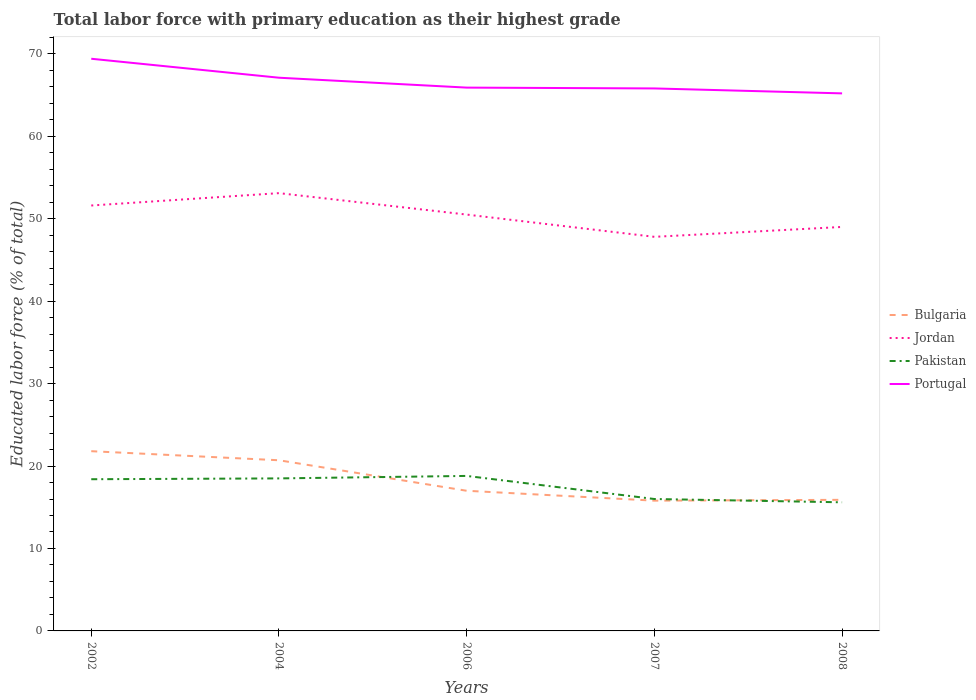Is the number of lines equal to the number of legend labels?
Your response must be concise. Yes. Across all years, what is the maximum percentage of total labor force with primary education in Portugal?
Your answer should be very brief. 65.2. In which year was the percentage of total labor force with primary education in Pakistan maximum?
Make the answer very short. 2008. What is the total percentage of total labor force with primary education in Portugal in the graph?
Offer a very short reply. 4.2. What is the difference between the highest and the second highest percentage of total labor force with primary education in Portugal?
Offer a terse response. 4.2. How many lines are there?
Offer a very short reply. 4. What is the difference between two consecutive major ticks on the Y-axis?
Ensure brevity in your answer.  10. Does the graph contain any zero values?
Provide a short and direct response. No. Where does the legend appear in the graph?
Provide a short and direct response. Center right. How are the legend labels stacked?
Your response must be concise. Vertical. What is the title of the graph?
Offer a terse response. Total labor force with primary education as their highest grade. What is the label or title of the Y-axis?
Ensure brevity in your answer.  Educated labor force (% of total). What is the Educated labor force (% of total) of Bulgaria in 2002?
Keep it short and to the point. 21.8. What is the Educated labor force (% of total) in Jordan in 2002?
Make the answer very short. 51.6. What is the Educated labor force (% of total) of Pakistan in 2002?
Your response must be concise. 18.4. What is the Educated labor force (% of total) of Portugal in 2002?
Offer a terse response. 69.4. What is the Educated labor force (% of total) in Bulgaria in 2004?
Offer a terse response. 20.7. What is the Educated labor force (% of total) in Jordan in 2004?
Make the answer very short. 53.1. What is the Educated labor force (% of total) of Pakistan in 2004?
Ensure brevity in your answer.  18.5. What is the Educated labor force (% of total) of Portugal in 2004?
Provide a short and direct response. 67.1. What is the Educated labor force (% of total) in Bulgaria in 2006?
Make the answer very short. 17. What is the Educated labor force (% of total) of Jordan in 2006?
Ensure brevity in your answer.  50.5. What is the Educated labor force (% of total) of Pakistan in 2006?
Keep it short and to the point. 18.8. What is the Educated labor force (% of total) in Portugal in 2006?
Give a very brief answer. 65.9. What is the Educated labor force (% of total) in Bulgaria in 2007?
Give a very brief answer. 15.8. What is the Educated labor force (% of total) in Jordan in 2007?
Keep it short and to the point. 47.8. What is the Educated labor force (% of total) of Portugal in 2007?
Your answer should be very brief. 65.8. What is the Educated labor force (% of total) of Bulgaria in 2008?
Your response must be concise. 15.9. What is the Educated labor force (% of total) of Jordan in 2008?
Make the answer very short. 49. What is the Educated labor force (% of total) in Pakistan in 2008?
Offer a terse response. 15.6. What is the Educated labor force (% of total) in Portugal in 2008?
Provide a short and direct response. 65.2. Across all years, what is the maximum Educated labor force (% of total) in Bulgaria?
Ensure brevity in your answer.  21.8. Across all years, what is the maximum Educated labor force (% of total) in Jordan?
Your response must be concise. 53.1. Across all years, what is the maximum Educated labor force (% of total) of Pakistan?
Provide a short and direct response. 18.8. Across all years, what is the maximum Educated labor force (% of total) in Portugal?
Your answer should be compact. 69.4. Across all years, what is the minimum Educated labor force (% of total) of Bulgaria?
Provide a succinct answer. 15.8. Across all years, what is the minimum Educated labor force (% of total) of Jordan?
Your answer should be very brief. 47.8. Across all years, what is the minimum Educated labor force (% of total) in Pakistan?
Offer a very short reply. 15.6. Across all years, what is the minimum Educated labor force (% of total) of Portugal?
Your answer should be compact. 65.2. What is the total Educated labor force (% of total) in Bulgaria in the graph?
Your answer should be very brief. 91.2. What is the total Educated labor force (% of total) in Jordan in the graph?
Your response must be concise. 252. What is the total Educated labor force (% of total) of Pakistan in the graph?
Ensure brevity in your answer.  87.3. What is the total Educated labor force (% of total) of Portugal in the graph?
Give a very brief answer. 333.4. What is the difference between the Educated labor force (% of total) of Bulgaria in 2002 and that in 2004?
Provide a short and direct response. 1.1. What is the difference between the Educated labor force (% of total) of Jordan in 2002 and that in 2004?
Your response must be concise. -1.5. What is the difference between the Educated labor force (% of total) in Bulgaria in 2002 and that in 2006?
Keep it short and to the point. 4.8. What is the difference between the Educated labor force (% of total) of Portugal in 2002 and that in 2006?
Keep it short and to the point. 3.5. What is the difference between the Educated labor force (% of total) of Jordan in 2002 and that in 2007?
Your answer should be compact. 3.8. What is the difference between the Educated labor force (% of total) in Pakistan in 2002 and that in 2007?
Offer a very short reply. 2.4. What is the difference between the Educated labor force (% of total) of Portugal in 2002 and that in 2007?
Ensure brevity in your answer.  3.6. What is the difference between the Educated labor force (% of total) in Bulgaria in 2002 and that in 2008?
Offer a terse response. 5.9. What is the difference between the Educated labor force (% of total) in Jordan in 2002 and that in 2008?
Your answer should be very brief. 2.6. What is the difference between the Educated labor force (% of total) in Portugal in 2002 and that in 2008?
Ensure brevity in your answer.  4.2. What is the difference between the Educated labor force (% of total) in Bulgaria in 2004 and that in 2007?
Give a very brief answer. 4.9. What is the difference between the Educated labor force (% of total) of Pakistan in 2004 and that in 2007?
Your answer should be very brief. 2.5. What is the difference between the Educated labor force (% of total) in Jordan in 2004 and that in 2008?
Make the answer very short. 4.1. What is the difference between the Educated labor force (% of total) in Bulgaria in 2006 and that in 2007?
Offer a very short reply. 1.2. What is the difference between the Educated labor force (% of total) in Jordan in 2006 and that in 2007?
Provide a short and direct response. 2.7. What is the difference between the Educated labor force (% of total) in Portugal in 2006 and that in 2007?
Give a very brief answer. 0.1. What is the difference between the Educated labor force (% of total) in Bulgaria in 2006 and that in 2008?
Keep it short and to the point. 1.1. What is the difference between the Educated labor force (% of total) of Jordan in 2006 and that in 2008?
Your response must be concise. 1.5. What is the difference between the Educated labor force (% of total) of Pakistan in 2006 and that in 2008?
Provide a short and direct response. 3.2. What is the difference between the Educated labor force (% of total) of Pakistan in 2007 and that in 2008?
Make the answer very short. 0.4. What is the difference between the Educated labor force (% of total) in Bulgaria in 2002 and the Educated labor force (% of total) in Jordan in 2004?
Your answer should be very brief. -31.3. What is the difference between the Educated labor force (% of total) of Bulgaria in 2002 and the Educated labor force (% of total) of Portugal in 2004?
Provide a succinct answer. -45.3. What is the difference between the Educated labor force (% of total) in Jordan in 2002 and the Educated labor force (% of total) in Pakistan in 2004?
Your answer should be compact. 33.1. What is the difference between the Educated labor force (% of total) of Jordan in 2002 and the Educated labor force (% of total) of Portugal in 2004?
Keep it short and to the point. -15.5. What is the difference between the Educated labor force (% of total) in Pakistan in 2002 and the Educated labor force (% of total) in Portugal in 2004?
Offer a very short reply. -48.7. What is the difference between the Educated labor force (% of total) of Bulgaria in 2002 and the Educated labor force (% of total) of Jordan in 2006?
Offer a very short reply. -28.7. What is the difference between the Educated labor force (% of total) in Bulgaria in 2002 and the Educated labor force (% of total) in Portugal in 2006?
Offer a very short reply. -44.1. What is the difference between the Educated labor force (% of total) of Jordan in 2002 and the Educated labor force (% of total) of Pakistan in 2006?
Ensure brevity in your answer.  32.8. What is the difference between the Educated labor force (% of total) in Jordan in 2002 and the Educated labor force (% of total) in Portugal in 2006?
Ensure brevity in your answer.  -14.3. What is the difference between the Educated labor force (% of total) in Pakistan in 2002 and the Educated labor force (% of total) in Portugal in 2006?
Your response must be concise. -47.5. What is the difference between the Educated labor force (% of total) of Bulgaria in 2002 and the Educated labor force (% of total) of Portugal in 2007?
Your response must be concise. -44. What is the difference between the Educated labor force (% of total) in Jordan in 2002 and the Educated labor force (% of total) in Pakistan in 2007?
Provide a succinct answer. 35.6. What is the difference between the Educated labor force (% of total) in Pakistan in 2002 and the Educated labor force (% of total) in Portugal in 2007?
Keep it short and to the point. -47.4. What is the difference between the Educated labor force (% of total) of Bulgaria in 2002 and the Educated labor force (% of total) of Jordan in 2008?
Provide a succinct answer. -27.2. What is the difference between the Educated labor force (% of total) of Bulgaria in 2002 and the Educated labor force (% of total) of Portugal in 2008?
Provide a short and direct response. -43.4. What is the difference between the Educated labor force (% of total) of Jordan in 2002 and the Educated labor force (% of total) of Portugal in 2008?
Provide a succinct answer. -13.6. What is the difference between the Educated labor force (% of total) in Pakistan in 2002 and the Educated labor force (% of total) in Portugal in 2008?
Your answer should be very brief. -46.8. What is the difference between the Educated labor force (% of total) of Bulgaria in 2004 and the Educated labor force (% of total) of Jordan in 2006?
Give a very brief answer. -29.8. What is the difference between the Educated labor force (% of total) of Bulgaria in 2004 and the Educated labor force (% of total) of Portugal in 2006?
Offer a terse response. -45.2. What is the difference between the Educated labor force (% of total) of Jordan in 2004 and the Educated labor force (% of total) of Pakistan in 2006?
Give a very brief answer. 34.3. What is the difference between the Educated labor force (% of total) of Jordan in 2004 and the Educated labor force (% of total) of Portugal in 2006?
Make the answer very short. -12.8. What is the difference between the Educated labor force (% of total) in Pakistan in 2004 and the Educated labor force (% of total) in Portugal in 2006?
Keep it short and to the point. -47.4. What is the difference between the Educated labor force (% of total) of Bulgaria in 2004 and the Educated labor force (% of total) of Jordan in 2007?
Provide a succinct answer. -27.1. What is the difference between the Educated labor force (% of total) of Bulgaria in 2004 and the Educated labor force (% of total) of Portugal in 2007?
Your response must be concise. -45.1. What is the difference between the Educated labor force (% of total) of Jordan in 2004 and the Educated labor force (% of total) of Pakistan in 2007?
Offer a terse response. 37.1. What is the difference between the Educated labor force (% of total) of Jordan in 2004 and the Educated labor force (% of total) of Portugal in 2007?
Give a very brief answer. -12.7. What is the difference between the Educated labor force (% of total) of Pakistan in 2004 and the Educated labor force (% of total) of Portugal in 2007?
Your response must be concise. -47.3. What is the difference between the Educated labor force (% of total) of Bulgaria in 2004 and the Educated labor force (% of total) of Jordan in 2008?
Give a very brief answer. -28.3. What is the difference between the Educated labor force (% of total) of Bulgaria in 2004 and the Educated labor force (% of total) of Pakistan in 2008?
Ensure brevity in your answer.  5.1. What is the difference between the Educated labor force (% of total) of Bulgaria in 2004 and the Educated labor force (% of total) of Portugal in 2008?
Give a very brief answer. -44.5. What is the difference between the Educated labor force (% of total) in Jordan in 2004 and the Educated labor force (% of total) in Pakistan in 2008?
Your answer should be compact. 37.5. What is the difference between the Educated labor force (% of total) of Pakistan in 2004 and the Educated labor force (% of total) of Portugal in 2008?
Keep it short and to the point. -46.7. What is the difference between the Educated labor force (% of total) of Bulgaria in 2006 and the Educated labor force (% of total) of Jordan in 2007?
Make the answer very short. -30.8. What is the difference between the Educated labor force (% of total) in Bulgaria in 2006 and the Educated labor force (% of total) in Pakistan in 2007?
Ensure brevity in your answer.  1. What is the difference between the Educated labor force (% of total) in Bulgaria in 2006 and the Educated labor force (% of total) in Portugal in 2007?
Keep it short and to the point. -48.8. What is the difference between the Educated labor force (% of total) in Jordan in 2006 and the Educated labor force (% of total) in Pakistan in 2007?
Provide a succinct answer. 34.5. What is the difference between the Educated labor force (% of total) in Jordan in 2006 and the Educated labor force (% of total) in Portugal in 2007?
Your response must be concise. -15.3. What is the difference between the Educated labor force (% of total) in Pakistan in 2006 and the Educated labor force (% of total) in Portugal in 2007?
Provide a succinct answer. -47. What is the difference between the Educated labor force (% of total) in Bulgaria in 2006 and the Educated labor force (% of total) in Jordan in 2008?
Give a very brief answer. -32. What is the difference between the Educated labor force (% of total) of Bulgaria in 2006 and the Educated labor force (% of total) of Pakistan in 2008?
Provide a succinct answer. 1.4. What is the difference between the Educated labor force (% of total) of Bulgaria in 2006 and the Educated labor force (% of total) of Portugal in 2008?
Provide a succinct answer. -48.2. What is the difference between the Educated labor force (% of total) of Jordan in 2006 and the Educated labor force (% of total) of Pakistan in 2008?
Provide a short and direct response. 34.9. What is the difference between the Educated labor force (% of total) of Jordan in 2006 and the Educated labor force (% of total) of Portugal in 2008?
Ensure brevity in your answer.  -14.7. What is the difference between the Educated labor force (% of total) in Pakistan in 2006 and the Educated labor force (% of total) in Portugal in 2008?
Keep it short and to the point. -46.4. What is the difference between the Educated labor force (% of total) of Bulgaria in 2007 and the Educated labor force (% of total) of Jordan in 2008?
Make the answer very short. -33.2. What is the difference between the Educated labor force (% of total) of Bulgaria in 2007 and the Educated labor force (% of total) of Portugal in 2008?
Your answer should be very brief. -49.4. What is the difference between the Educated labor force (% of total) in Jordan in 2007 and the Educated labor force (% of total) in Pakistan in 2008?
Your answer should be compact. 32.2. What is the difference between the Educated labor force (% of total) of Jordan in 2007 and the Educated labor force (% of total) of Portugal in 2008?
Make the answer very short. -17.4. What is the difference between the Educated labor force (% of total) of Pakistan in 2007 and the Educated labor force (% of total) of Portugal in 2008?
Keep it short and to the point. -49.2. What is the average Educated labor force (% of total) of Bulgaria per year?
Make the answer very short. 18.24. What is the average Educated labor force (% of total) in Jordan per year?
Keep it short and to the point. 50.4. What is the average Educated labor force (% of total) of Pakistan per year?
Ensure brevity in your answer.  17.46. What is the average Educated labor force (% of total) in Portugal per year?
Offer a very short reply. 66.68. In the year 2002, what is the difference between the Educated labor force (% of total) of Bulgaria and Educated labor force (% of total) of Jordan?
Your answer should be compact. -29.8. In the year 2002, what is the difference between the Educated labor force (% of total) of Bulgaria and Educated labor force (% of total) of Pakistan?
Offer a very short reply. 3.4. In the year 2002, what is the difference between the Educated labor force (% of total) in Bulgaria and Educated labor force (% of total) in Portugal?
Offer a terse response. -47.6. In the year 2002, what is the difference between the Educated labor force (% of total) of Jordan and Educated labor force (% of total) of Pakistan?
Make the answer very short. 33.2. In the year 2002, what is the difference between the Educated labor force (% of total) of Jordan and Educated labor force (% of total) of Portugal?
Offer a very short reply. -17.8. In the year 2002, what is the difference between the Educated labor force (% of total) in Pakistan and Educated labor force (% of total) in Portugal?
Provide a short and direct response. -51. In the year 2004, what is the difference between the Educated labor force (% of total) of Bulgaria and Educated labor force (% of total) of Jordan?
Keep it short and to the point. -32.4. In the year 2004, what is the difference between the Educated labor force (% of total) of Bulgaria and Educated labor force (% of total) of Portugal?
Make the answer very short. -46.4. In the year 2004, what is the difference between the Educated labor force (% of total) of Jordan and Educated labor force (% of total) of Pakistan?
Your answer should be very brief. 34.6. In the year 2004, what is the difference between the Educated labor force (% of total) in Jordan and Educated labor force (% of total) in Portugal?
Your response must be concise. -14. In the year 2004, what is the difference between the Educated labor force (% of total) of Pakistan and Educated labor force (% of total) of Portugal?
Provide a succinct answer. -48.6. In the year 2006, what is the difference between the Educated labor force (% of total) in Bulgaria and Educated labor force (% of total) in Jordan?
Make the answer very short. -33.5. In the year 2006, what is the difference between the Educated labor force (% of total) of Bulgaria and Educated labor force (% of total) of Portugal?
Ensure brevity in your answer.  -48.9. In the year 2006, what is the difference between the Educated labor force (% of total) of Jordan and Educated labor force (% of total) of Pakistan?
Keep it short and to the point. 31.7. In the year 2006, what is the difference between the Educated labor force (% of total) of Jordan and Educated labor force (% of total) of Portugal?
Make the answer very short. -15.4. In the year 2006, what is the difference between the Educated labor force (% of total) in Pakistan and Educated labor force (% of total) in Portugal?
Your answer should be very brief. -47.1. In the year 2007, what is the difference between the Educated labor force (% of total) in Bulgaria and Educated labor force (% of total) in Jordan?
Ensure brevity in your answer.  -32. In the year 2007, what is the difference between the Educated labor force (% of total) of Bulgaria and Educated labor force (% of total) of Portugal?
Offer a very short reply. -50. In the year 2007, what is the difference between the Educated labor force (% of total) of Jordan and Educated labor force (% of total) of Pakistan?
Ensure brevity in your answer.  31.8. In the year 2007, what is the difference between the Educated labor force (% of total) of Jordan and Educated labor force (% of total) of Portugal?
Your answer should be compact. -18. In the year 2007, what is the difference between the Educated labor force (% of total) of Pakistan and Educated labor force (% of total) of Portugal?
Make the answer very short. -49.8. In the year 2008, what is the difference between the Educated labor force (% of total) in Bulgaria and Educated labor force (% of total) in Jordan?
Keep it short and to the point. -33.1. In the year 2008, what is the difference between the Educated labor force (% of total) in Bulgaria and Educated labor force (% of total) in Portugal?
Make the answer very short. -49.3. In the year 2008, what is the difference between the Educated labor force (% of total) of Jordan and Educated labor force (% of total) of Pakistan?
Provide a short and direct response. 33.4. In the year 2008, what is the difference between the Educated labor force (% of total) of Jordan and Educated labor force (% of total) of Portugal?
Make the answer very short. -16.2. In the year 2008, what is the difference between the Educated labor force (% of total) in Pakistan and Educated labor force (% of total) in Portugal?
Ensure brevity in your answer.  -49.6. What is the ratio of the Educated labor force (% of total) of Bulgaria in 2002 to that in 2004?
Ensure brevity in your answer.  1.05. What is the ratio of the Educated labor force (% of total) in Jordan in 2002 to that in 2004?
Your response must be concise. 0.97. What is the ratio of the Educated labor force (% of total) of Pakistan in 2002 to that in 2004?
Provide a succinct answer. 0.99. What is the ratio of the Educated labor force (% of total) in Portugal in 2002 to that in 2004?
Provide a short and direct response. 1.03. What is the ratio of the Educated labor force (% of total) of Bulgaria in 2002 to that in 2006?
Your answer should be compact. 1.28. What is the ratio of the Educated labor force (% of total) in Jordan in 2002 to that in 2006?
Provide a succinct answer. 1.02. What is the ratio of the Educated labor force (% of total) of Pakistan in 2002 to that in 2006?
Offer a terse response. 0.98. What is the ratio of the Educated labor force (% of total) of Portugal in 2002 to that in 2006?
Keep it short and to the point. 1.05. What is the ratio of the Educated labor force (% of total) in Bulgaria in 2002 to that in 2007?
Your answer should be compact. 1.38. What is the ratio of the Educated labor force (% of total) of Jordan in 2002 to that in 2007?
Keep it short and to the point. 1.08. What is the ratio of the Educated labor force (% of total) in Pakistan in 2002 to that in 2007?
Keep it short and to the point. 1.15. What is the ratio of the Educated labor force (% of total) in Portugal in 2002 to that in 2007?
Provide a short and direct response. 1.05. What is the ratio of the Educated labor force (% of total) in Bulgaria in 2002 to that in 2008?
Keep it short and to the point. 1.37. What is the ratio of the Educated labor force (% of total) in Jordan in 2002 to that in 2008?
Your answer should be compact. 1.05. What is the ratio of the Educated labor force (% of total) in Pakistan in 2002 to that in 2008?
Your answer should be very brief. 1.18. What is the ratio of the Educated labor force (% of total) in Portugal in 2002 to that in 2008?
Give a very brief answer. 1.06. What is the ratio of the Educated labor force (% of total) in Bulgaria in 2004 to that in 2006?
Your response must be concise. 1.22. What is the ratio of the Educated labor force (% of total) of Jordan in 2004 to that in 2006?
Your answer should be compact. 1.05. What is the ratio of the Educated labor force (% of total) in Pakistan in 2004 to that in 2006?
Give a very brief answer. 0.98. What is the ratio of the Educated labor force (% of total) of Portugal in 2004 to that in 2006?
Make the answer very short. 1.02. What is the ratio of the Educated labor force (% of total) of Bulgaria in 2004 to that in 2007?
Offer a very short reply. 1.31. What is the ratio of the Educated labor force (% of total) of Jordan in 2004 to that in 2007?
Offer a terse response. 1.11. What is the ratio of the Educated labor force (% of total) of Pakistan in 2004 to that in 2007?
Give a very brief answer. 1.16. What is the ratio of the Educated labor force (% of total) in Portugal in 2004 to that in 2007?
Make the answer very short. 1.02. What is the ratio of the Educated labor force (% of total) in Bulgaria in 2004 to that in 2008?
Your answer should be very brief. 1.3. What is the ratio of the Educated labor force (% of total) of Jordan in 2004 to that in 2008?
Your response must be concise. 1.08. What is the ratio of the Educated labor force (% of total) of Pakistan in 2004 to that in 2008?
Make the answer very short. 1.19. What is the ratio of the Educated labor force (% of total) in Portugal in 2004 to that in 2008?
Make the answer very short. 1.03. What is the ratio of the Educated labor force (% of total) of Bulgaria in 2006 to that in 2007?
Make the answer very short. 1.08. What is the ratio of the Educated labor force (% of total) of Jordan in 2006 to that in 2007?
Offer a very short reply. 1.06. What is the ratio of the Educated labor force (% of total) of Pakistan in 2006 to that in 2007?
Provide a succinct answer. 1.18. What is the ratio of the Educated labor force (% of total) of Bulgaria in 2006 to that in 2008?
Offer a very short reply. 1.07. What is the ratio of the Educated labor force (% of total) in Jordan in 2006 to that in 2008?
Provide a short and direct response. 1.03. What is the ratio of the Educated labor force (% of total) in Pakistan in 2006 to that in 2008?
Ensure brevity in your answer.  1.21. What is the ratio of the Educated labor force (% of total) of Portugal in 2006 to that in 2008?
Give a very brief answer. 1.01. What is the ratio of the Educated labor force (% of total) of Jordan in 2007 to that in 2008?
Provide a short and direct response. 0.98. What is the ratio of the Educated labor force (% of total) of Pakistan in 2007 to that in 2008?
Make the answer very short. 1.03. What is the ratio of the Educated labor force (% of total) of Portugal in 2007 to that in 2008?
Make the answer very short. 1.01. What is the difference between the highest and the second highest Educated labor force (% of total) in Jordan?
Offer a very short reply. 1.5. What is the difference between the highest and the lowest Educated labor force (% of total) of Jordan?
Give a very brief answer. 5.3. 